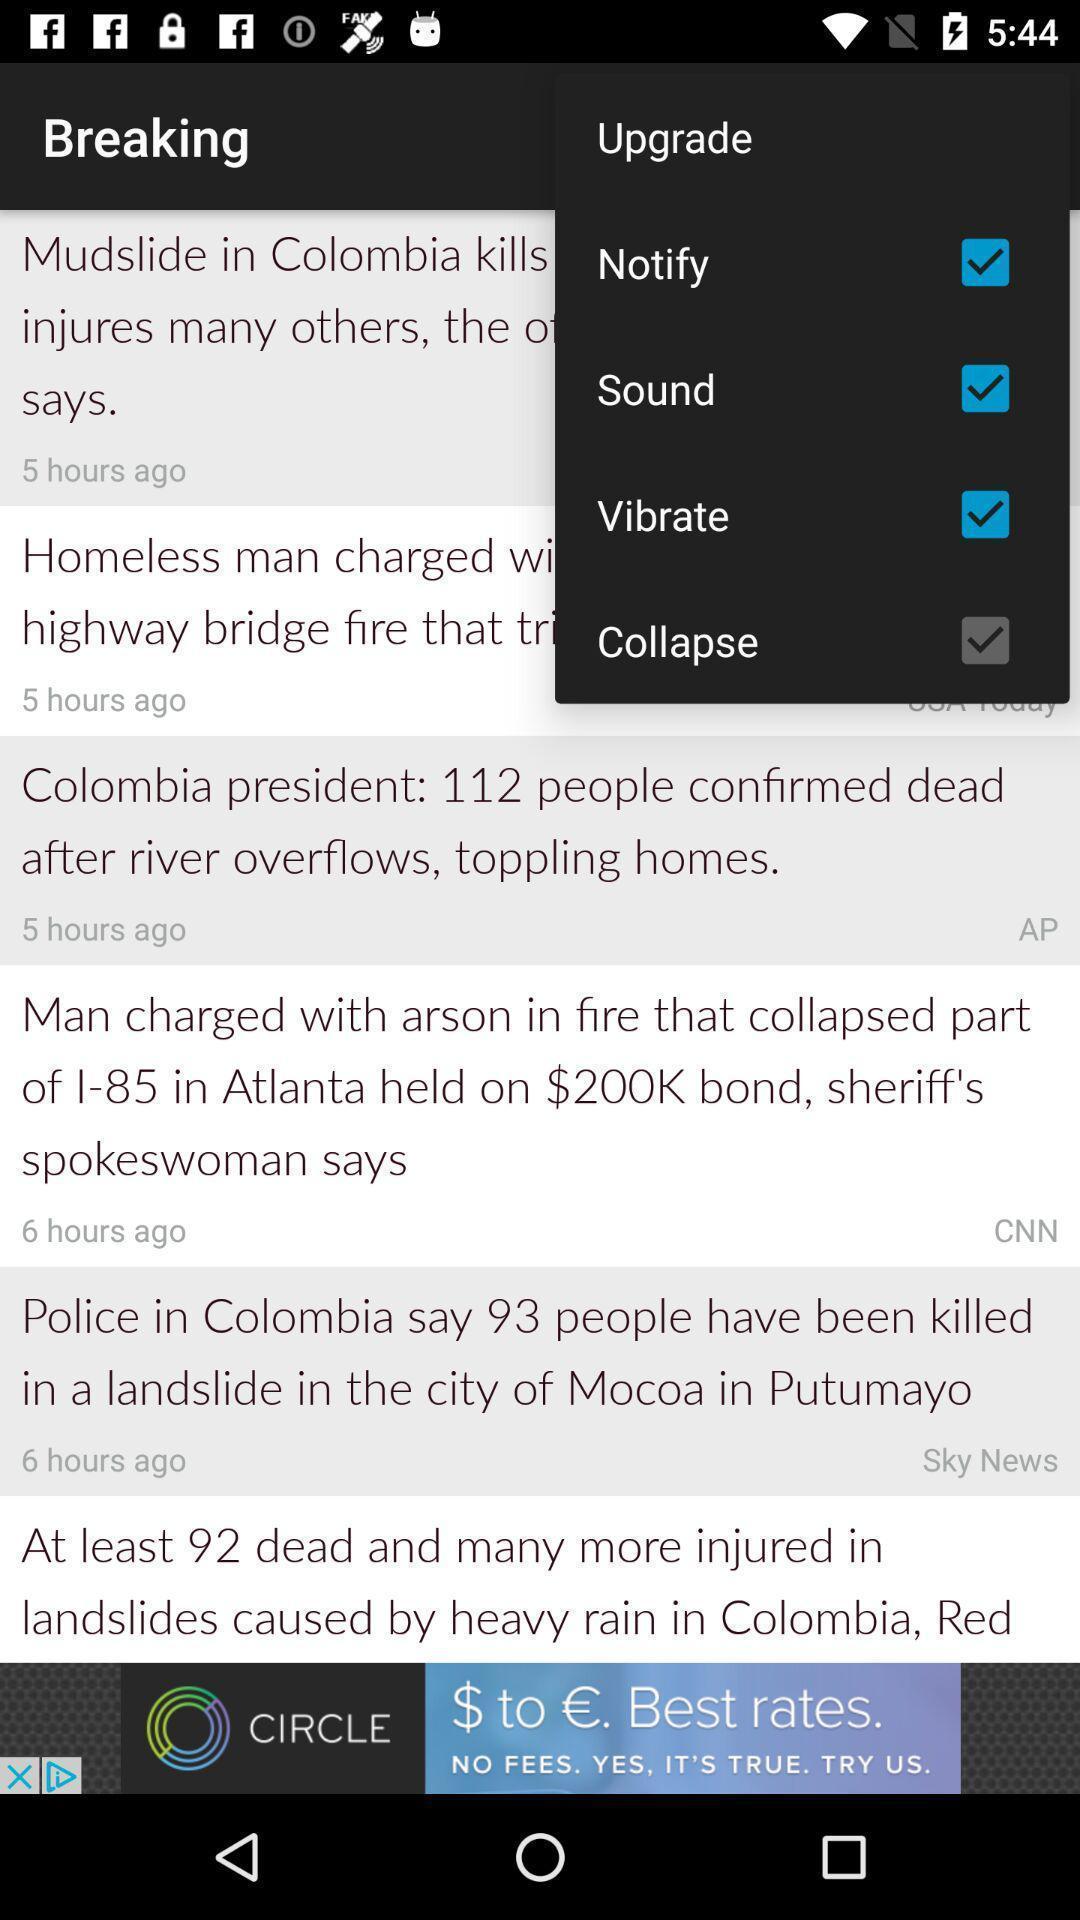What can you discern from this picture? Widget is showing different settings. 